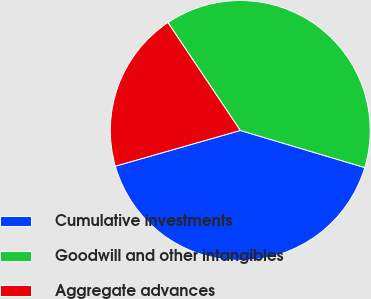Convert chart to OTSL. <chart><loc_0><loc_0><loc_500><loc_500><pie_chart><fcel>Cumulative investments<fcel>Goodwill and other intangibles<fcel>Aggregate advances<nl><fcel>40.96%<fcel>39.01%<fcel>20.03%<nl></chart> 